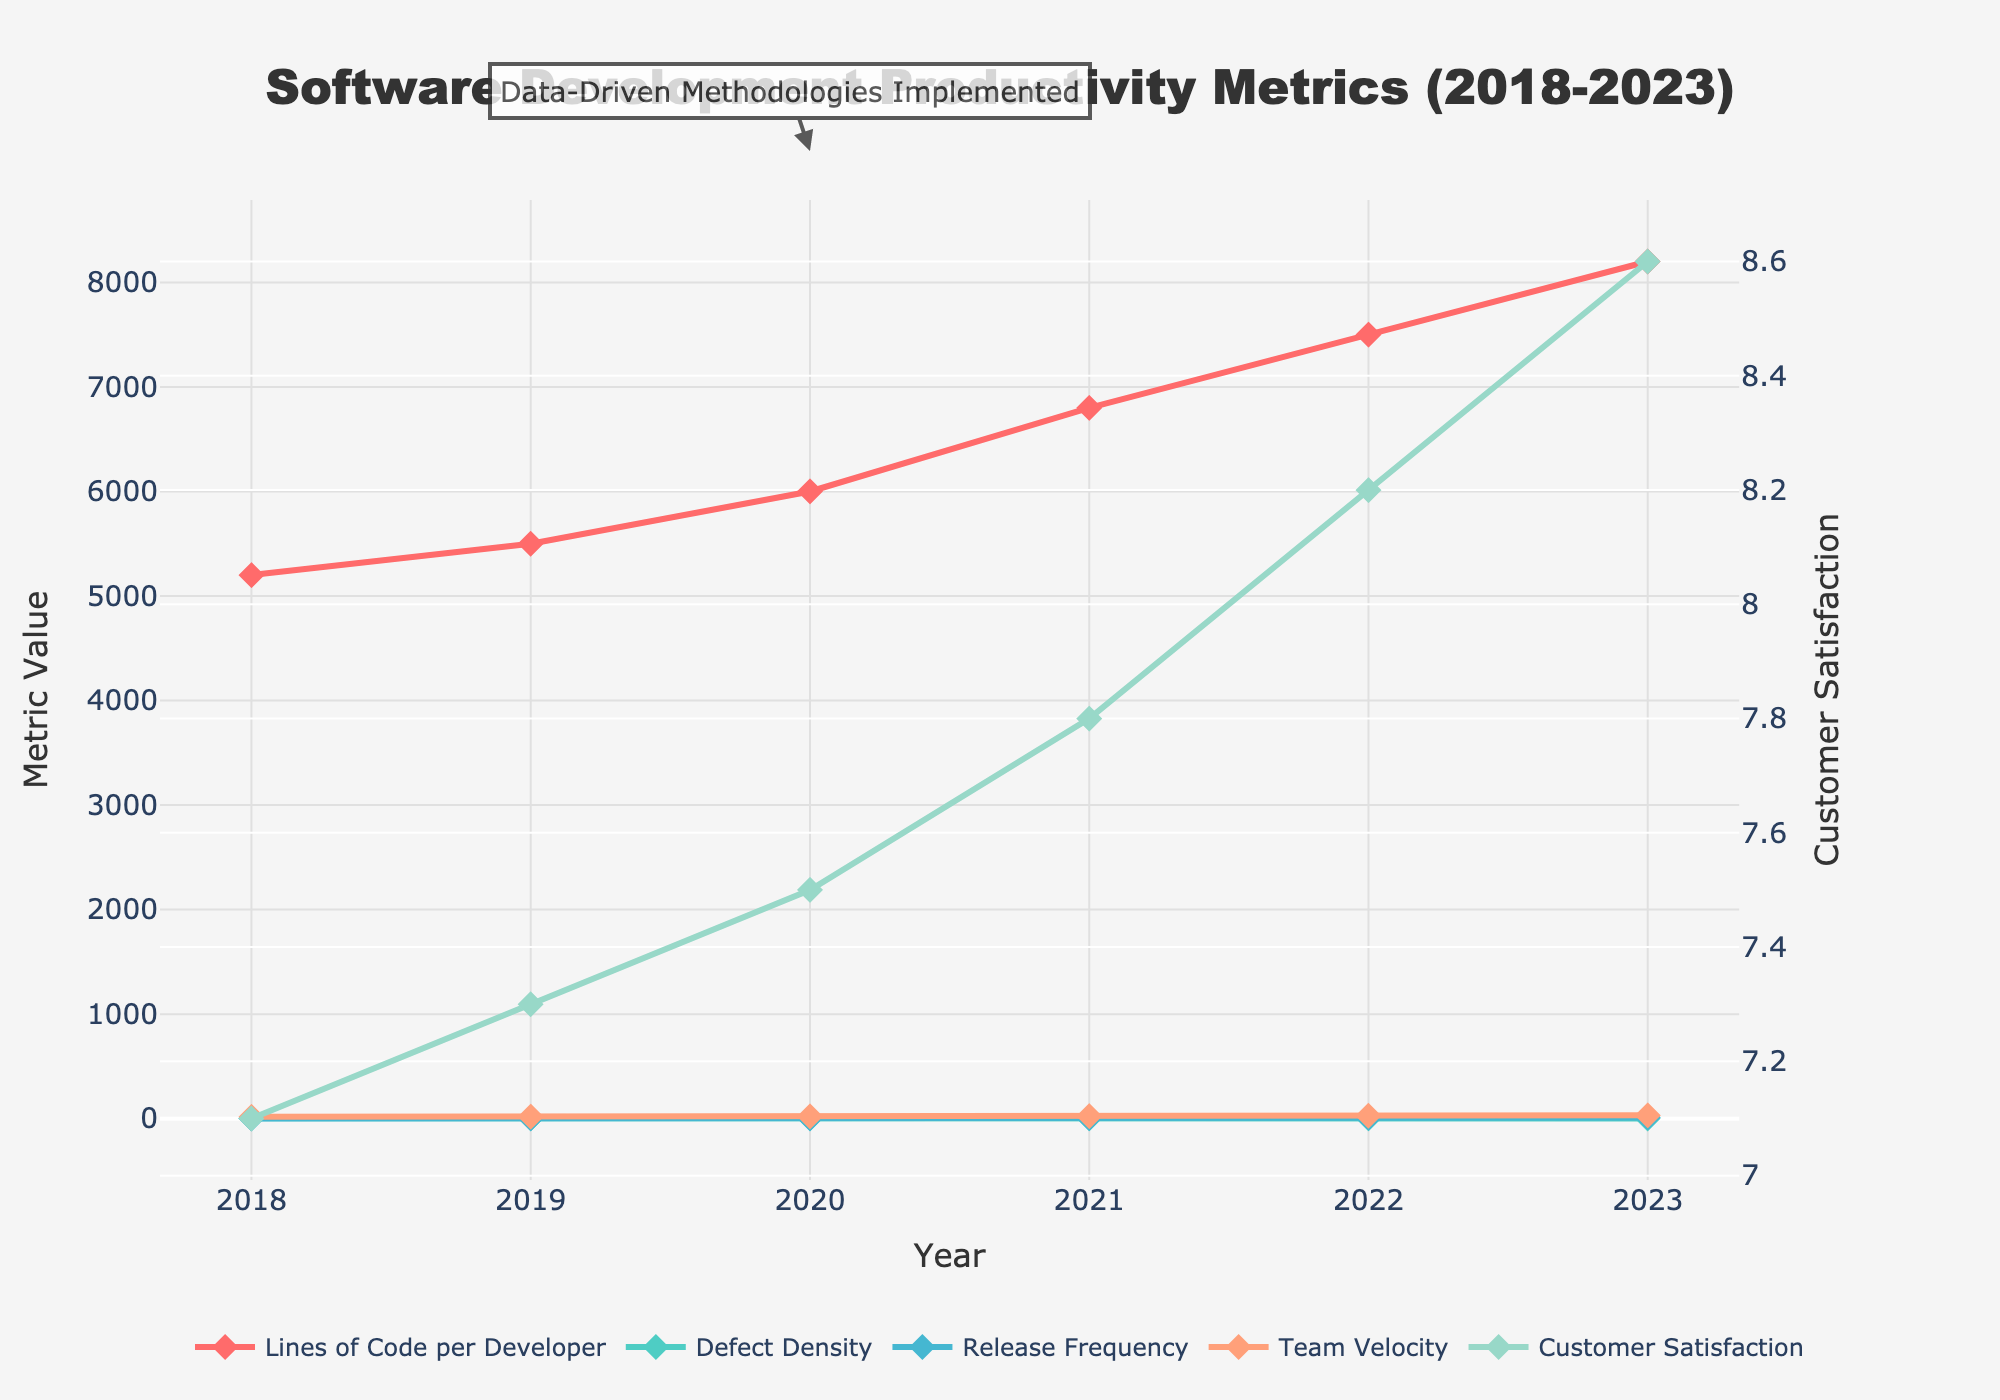What general trend do you notice for Lines of Code per Developer from 2018 to 2023? The Lines of Code per Developer metric shows an overall increasing trend from 2018 (5200) to 2023 (8200).
Answer: Increasing trend How does Defect Density change over the years, and what could be inferred about software quality? Defect Density decreases from 4.2 in 2018 to 1.8 in 2023. A decreasing Defect Density indicates an improvement in software quality over the years.
Answer: Decreasing trend, improved software quality What is the rate of increase for Customer Satisfaction from 2018 to 2023? Customer Satisfaction increases from 7.1 in 2018 to 8.6 in 2023. The increase in Customer Satisfaction is 8.6 - 7.1 = 1.5 over 6 years. The average annual increase is 1.5 / 6 ≈ 0.25.
Answer: 0.25 per year Which year shows the highest increase in Team Velocity, and by how much does it increase compared to the previous year? Team Velocity increases significantly from 25 in 2021 to 28 in 2022. The increase is 28 - 25 = 3.
Answer: 2022, 3 What noticeable event does the annotation "Data-Driven Methodologies Implemented" correspond to, and how can it be related to changes in the metrics? The annotation corresponds to the year 2020. After the implementation of data-driven methodologies, significant improvements in all metrics, especially Team Velocity, Release Frequency, and Customer Satisfaction, can be observed.
Answer: 2020, improvements post-2020 Compare the trend of Release Frequency with that of Defect Density from 2018 to 2023. Release Frequency increases from 2 in 2018 to 12 in 2023, whereas Defect Density decreases from 4.2 in 2018 to 1.8 in 2023. Opposite trends suggest more releases with fewer defects over time.
Answer: Release Frequency Up, Defect Density Down What can be inferred about productivity and quality focus in the team before and after 2020? Before 2020, there is a gradual improvement in productivity (Lines of Code per Developer and Release Frequency) and a slight decrease in Defect Density. After 2020, there is a more rapid improvement in productivity and a sharper decrease in Defect Density, suggesting a stronger emphasis on both productivity and quality post-implementation of data-driven methodologies.
Answer: Improved productivity and quality post-2020 By how much did Customer Satisfaction increase during the fastest growth period, and when did that occur? Customer Satisfaction increased from 7.8 in 2021 to 8.2 in 2022, a total increase of 0.4, which is the fastest annual increase compared to other years.
Answer: 0.4, 2021-2022 Which metric has the least variability over the years, and what does it suggest? Defect Density shows a consistent decline, but Customer Satisfaction has steady increases with smaller increments each year. This suggests sustained improvement but less variability in Customer Satisfaction compared to other metrics.
Answer: Customer Satisfaction 